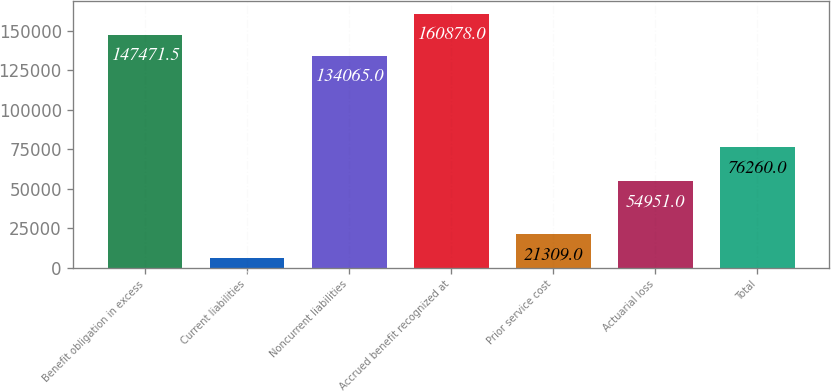<chart> <loc_0><loc_0><loc_500><loc_500><bar_chart><fcel>Benefit obligation in excess<fcel>Current liabilities<fcel>Noncurrent liabilities<fcel>Accrued benefit recognized at<fcel>Prior service cost<fcel>Actuarial loss<fcel>Total<nl><fcel>147472<fcel>6290<fcel>134065<fcel>160878<fcel>21309<fcel>54951<fcel>76260<nl></chart> 